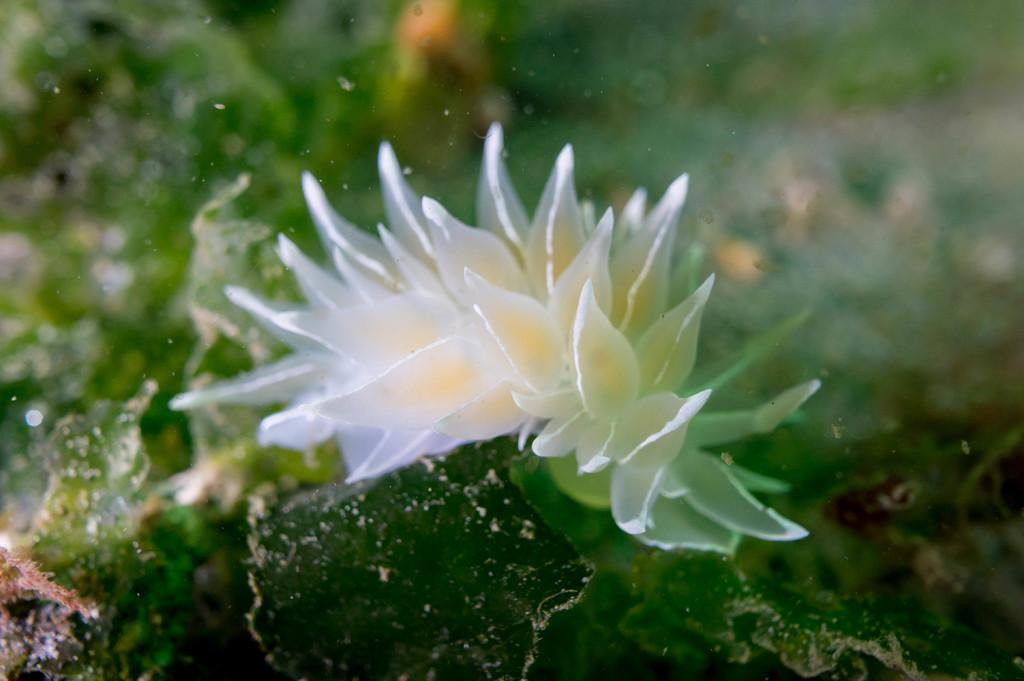What type of flowers can be seen in the image? There are white color flowers in the image. What else is visible in the image besides the flowers? Water is visible in the image. What color is the background of the image? The background of the image is green. How many cows are standing near the pin in the image? There are no cows or pins present in the image. What type of tree can be seen in the image? There is no tree visible in the image; it only features white flowers, water, and a green background. 